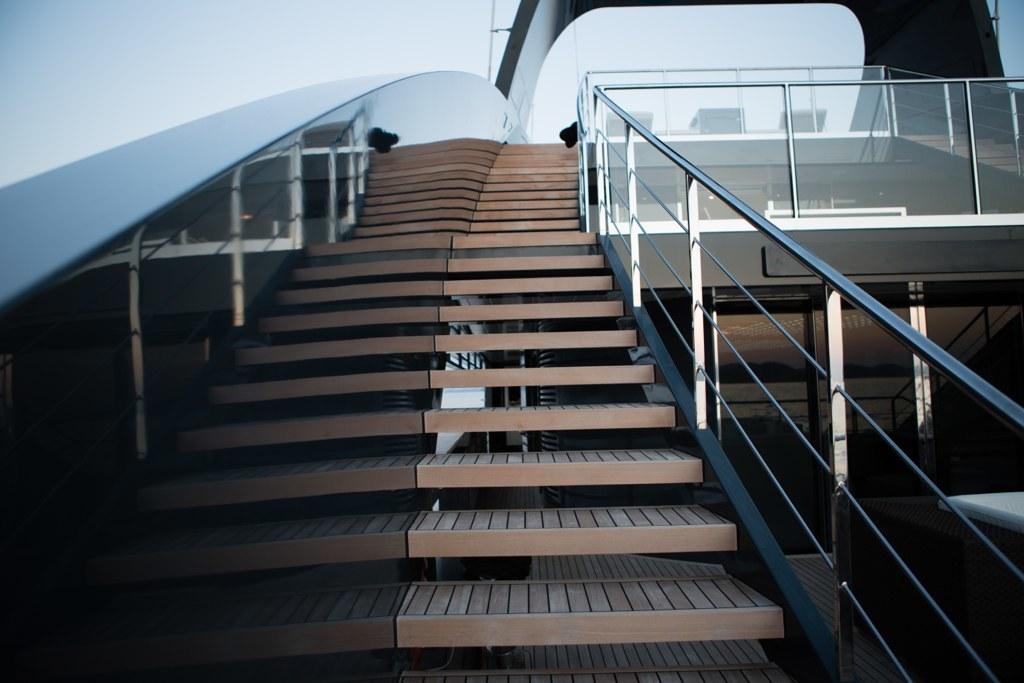How would you summarize this image in a sentence or two? In the foreground of this image, there are stairs, railing, wooden floor, an object on the right, glass wall, glass railing and it seems like a roof at the top. We can also see the sky. 